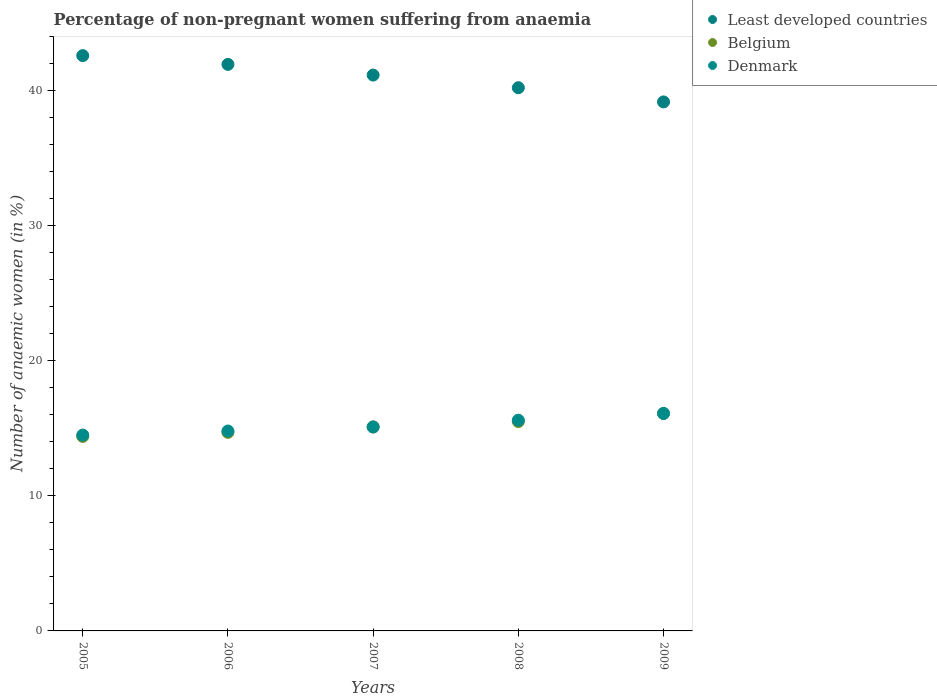How many different coloured dotlines are there?
Ensure brevity in your answer.  3. Is the number of dotlines equal to the number of legend labels?
Offer a terse response. Yes. What is the percentage of non-pregnant women suffering from anaemia in Least developed countries in 2007?
Keep it short and to the point. 41.15. Across all years, what is the minimum percentage of non-pregnant women suffering from anaemia in Least developed countries?
Provide a succinct answer. 39.16. In which year was the percentage of non-pregnant women suffering from anaemia in Denmark minimum?
Ensure brevity in your answer.  2005. What is the total percentage of non-pregnant women suffering from anaemia in Least developed countries in the graph?
Offer a terse response. 205.06. What is the difference between the percentage of non-pregnant women suffering from anaemia in Denmark in 2006 and that in 2008?
Provide a succinct answer. -0.8. What is the difference between the percentage of non-pregnant women suffering from anaemia in Belgium in 2009 and the percentage of non-pregnant women suffering from anaemia in Denmark in 2008?
Provide a succinct answer. 0.5. What is the average percentage of non-pregnant women suffering from anaemia in Denmark per year?
Ensure brevity in your answer.  15.22. In the year 2006, what is the difference between the percentage of non-pregnant women suffering from anaemia in Least developed countries and percentage of non-pregnant women suffering from anaemia in Belgium?
Provide a short and direct response. 27.24. What is the ratio of the percentage of non-pregnant women suffering from anaemia in Least developed countries in 2006 to that in 2009?
Your answer should be compact. 1.07. Is the percentage of non-pregnant women suffering from anaemia in Belgium in 2006 less than that in 2007?
Give a very brief answer. Yes. What is the difference between the highest and the second highest percentage of non-pregnant women suffering from anaemia in Denmark?
Keep it short and to the point. 0.5. What is the difference between the highest and the lowest percentage of non-pregnant women suffering from anaemia in Least developed countries?
Offer a terse response. 3.43. In how many years, is the percentage of non-pregnant women suffering from anaemia in Least developed countries greater than the average percentage of non-pregnant women suffering from anaemia in Least developed countries taken over all years?
Your answer should be very brief. 3. Is the percentage of non-pregnant women suffering from anaemia in Belgium strictly greater than the percentage of non-pregnant women suffering from anaemia in Denmark over the years?
Give a very brief answer. No. Is the percentage of non-pregnant women suffering from anaemia in Denmark strictly less than the percentage of non-pregnant women suffering from anaemia in Least developed countries over the years?
Your answer should be very brief. Yes. How many dotlines are there?
Offer a terse response. 3. How many years are there in the graph?
Keep it short and to the point. 5. Are the values on the major ticks of Y-axis written in scientific E-notation?
Your answer should be very brief. No. Does the graph contain any zero values?
Provide a succinct answer. No. Does the graph contain grids?
Make the answer very short. No. How are the legend labels stacked?
Give a very brief answer. Vertical. What is the title of the graph?
Keep it short and to the point. Percentage of non-pregnant women suffering from anaemia. What is the label or title of the X-axis?
Provide a short and direct response. Years. What is the label or title of the Y-axis?
Keep it short and to the point. Number of anaemic women (in %). What is the Number of anaemic women (in %) in Least developed countries in 2005?
Make the answer very short. 42.59. What is the Number of anaemic women (in %) in Belgium in 2005?
Your answer should be very brief. 14.4. What is the Number of anaemic women (in %) in Denmark in 2005?
Your answer should be compact. 14.5. What is the Number of anaemic women (in %) in Least developed countries in 2006?
Provide a short and direct response. 41.94. What is the Number of anaemic women (in %) of Belgium in 2006?
Offer a very short reply. 14.7. What is the Number of anaemic women (in %) of Least developed countries in 2007?
Your answer should be very brief. 41.15. What is the Number of anaemic women (in %) in Belgium in 2007?
Your response must be concise. 15.1. What is the Number of anaemic women (in %) of Denmark in 2007?
Your response must be concise. 15.1. What is the Number of anaemic women (in %) in Least developed countries in 2008?
Your answer should be compact. 40.21. What is the Number of anaemic women (in %) in Denmark in 2008?
Your answer should be compact. 15.6. What is the Number of anaemic women (in %) of Least developed countries in 2009?
Offer a terse response. 39.16. What is the Number of anaemic women (in %) of Denmark in 2009?
Offer a very short reply. 16.1. Across all years, what is the maximum Number of anaemic women (in %) of Least developed countries?
Keep it short and to the point. 42.59. Across all years, what is the minimum Number of anaemic women (in %) of Least developed countries?
Your answer should be compact. 39.16. What is the total Number of anaemic women (in %) in Least developed countries in the graph?
Provide a short and direct response. 205.06. What is the total Number of anaemic women (in %) in Belgium in the graph?
Your answer should be very brief. 75.8. What is the total Number of anaemic women (in %) of Denmark in the graph?
Your answer should be compact. 76.1. What is the difference between the Number of anaemic women (in %) of Least developed countries in 2005 and that in 2006?
Your answer should be compact. 0.65. What is the difference between the Number of anaemic women (in %) of Denmark in 2005 and that in 2006?
Ensure brevity in your answer.  -0.3. What is the difference between the Number of anaemic women (in %) of Least developed countries in 2005 and that in 2007?
Your response must be concise. 1.44. What is the difference between the Number of anaemic women (in %) of Belgium in 2005 and that in 2007?
Provide a succinct answer. -0.7. What is the difference between the Number of anaemic women (in %) of Denmark in 2005 and that in 2007?
Ensure brevity in your answer.  -0.6. What is the difference between the Number of anaemic women (in %) in Least developed countries in 2005 and that in 2008?
Your answer should be very brief. 2.38. What is the difference between the Number of anaemic women (in %) of Denmark in 2005 and that in 2008?
Give a very brief answer. -1.1. What is the difference between the Number of anaemic women (in %) in Least developed countries in 2005 and that in 2009?
Your answer should be compact. 3.43. What is the difference between the Number of anaemic women (in %) of Belgium in 2005 and that in 2009?
Offer a very short reply. -1.7. What is the difference between the Number of anaemic women (in %) in Denmark in 2005 and that in 2009?
Make the answer very short. -1.6. What is the difference between the Number of anaemic women (in %) in Least developed countries in 2006 and that in 2007?
Offer a very short reply. 0.79. What is the difference between the Number of anaemic women (in %) of Belgium in 2006 and that in 2007?
Provide a short and direct response. -0.4. What is the difference between the Number of anaemic women (in %) of Denmark in 2006 and that in 2007?
Your answer should be compact. -0.3. What is the difference between the Number of anaemic women (in %) of Least developed countries in 2006 and that in 2008?
Your answer should be very brief. 1.73. What is the difference between the Number of anaemic women (in %) in Belgium in 2006 and that in 2008?
Make the answer very short. -0.8. What is the difference between the Number of anaemic women (in %) of Denmark in 2006 and that in 2008?
Offer a terse response. -0.8. What is the difference between the Number of anaemic women (in %) of Least developed countries in 2006 and that in 2009?
Keep it short and to the point. 2.78. What is the difference between the Number of anaemic women (in %) in Belgium in 2006 and that in 2009?
Your answer should be very brief. -1.4. What is the difference between the Number of anaemic women (in %) of Least developed countries in 2007 and that in 2008?
Your response must be concise. 0.94. What is the difference between the Number of anaemic women (in %) of Belgium in 2007 and that in 2008?
Your response must be concise. -0.4. What is the difference between the Number of anaemic women (in %) of Least developed countries in 2007 and that in 2009?
Offer a terse response. 1.99. What is the difference between the Number of anaemic women (in %) in Least developed countries in 2008 and that in 2009?
Your answer should be very brief. 1.05. What is the difference between the Number of anaemic women (in %) of Belgium in 2008 and that in 2009?
Your answer should be very brief. -0.6. What is the difference between the Number of anaemic women (in %) in Denmark in 2008 and that in 2009?
Make the answer very short. -0.5. What is the difference between the Number of anaemic women (in %) of Least developed countries in 2005 and the Number of anaemic women (in %) of Belgium in 2006?
Provide a short and direct response. 27.89. What is the difference between the Number of anaemic women (in %) of Least developed countries in 2005 and the Number of anaemic women (in %) of Denmark in 2006?
Make the answer very short. 27.79. What is the difference between the Number of anaemic women (in %) in Least developed countries in 2005 and the Number of anaemic women (in %) in Belgium in 2007?
Provide a succinct answer. 27.49. What is the difference between the Number of anaemic women (in %) of Least developed countries in 2005 and the Number of anaemic women (in %) of Denmark in 2007?
Provide a succinct answer. 27.49. What is the difference between the Number of anaemic women (in %) in Least developed countries in 2005 and the Number of anaemic women (in %) in Belgium in 2008?
Make the answer very short. 27.09. What is the difference between the Number of anaemic women (in %) of Least developed countries in 2005 and the Number of anaemic women (in %) of Denmark in 2008?
Keep it short and to the point. 26.99. What is the difference between the Number of anaemic women (in %) in Belgium in 2005 and the Number of anaemic women (in %) in Denmark in 2008?
Your answer should be compact. -1.2. What is the difference between the Number of anaemic women (in %) in Least developed countries in 2005 and the Number of anaemic women (in %) in Belgium in 2009?
Give a very brief answer. 26.49. What is the difference between the Number of anaemic women (in %) in Least developed countries in 2005 and the Number of anaemic women (in %) in Denmark in 2009?
Make the answer very short. 26.49. What is the difference between the Number of anaemic women (in %) in Belgium in 2005 and the Number of anaemic women (in %) in Denmark in 2009?
Keep it short and to the point. -1.7. What is the difference between the Number of anaemic women (in %) in Least developed countries in 2006 and the Number of anaemic women (in %) in Belgium in 2007?
Offer a terse response. 26.84. What is the difference between the Number of anaemic women (in %) of Least developed countries in 2006 and the Number of anaemic women (in %) of Denmark in 2007?
Provide a short and direct response. 26.84. What is the difference between the Number of anaemic women (in %) in Belgium in 2006 and the Number of anaemic women (in %) in Denmark in 2007?
Offer a very short reply. -0.4. What is the difference between the Number of anaemic women (in %) of Least developed countries in 2006 and the Number of anaemic women (in %) of Belgium in 2008?
Your response must be concise. 26.44. What is the difference between the Number of anaemic women (in %) of Least developed countries in 2006 and the Number of anaemic women (in %) of Denmark in 2008?
Offer a terse response. 26.34. What is the difference between the Number of anaemic women (in %) in Belgium in 2006 and the Number of anaemic women (in %) in Denmark in 2008?
Offer a terse response. -0.9. What is the difference between the Number of anaemic women (in %) of Least developed countries in 2006 and the Number of anaemic women (in %) of Belgium in 2009?
Your answer should be compact. 25.84. What is the difference between the Number of anaemic women (in %) of Least developed countries in 2006 and the Number of anaemic women (in %) of Denmark in 2009?
Your answer should be compact. 25.84. What is the difference between the Number of anaemic women (in %) of Least developed countries in 2007 and the Number of anaemic women (in %) of Belgium in 2008?
Offer a terse response. 25.65. What is the difference between the Number of anaemic women (in %) of Least developed countries in 2007 and the Number of anaemic women (in %) of Denmark in 2008?
Give a very brief answer. 25.55. What is the difference between the Number of anaemic women (in %) in Least developed countries in 2007 and the Number of anaemic women (in %) in Belgium in 2009?
Make the answer very short. 25.05. What is the difference between the Number of anaemic women (in %) in Least developed countries in 2007 and the Number of anaemic women (in %) in Denmark in 2009?
Your answer should be compact. 25.05. What is the difference between the Number of anaemic women (in %) of Belgium in 2007 and the Number of anaemic women (in %) of Denmark in 2009?
Your answer should be very brief. -1. What is the difference between the Number of anaemic women (in %) of Least developed countries in 2008 and the Number of anaemic women (in %) of Belgium in 2009?
Provide a short and direct response. 24.11. What is the difference between the Number of anaemic women (in %) of Least developed countries in 2008 and the Number of anaemic women (in %) of Denmark in 2009?
Make the answer very short. 24.11. What is the average Number of anaemic women (in %) of Least developed countries per year?
Offer a very short reply. 41.01. What is the average Number of anaemic women (in %) of Belgium per year?
Offer a very short reply. 15.16. What is the average Number of anaemic women (in %) in Denmark per year?
Keep it short and to the point. 15.22. In the year 2005, what is the difference between the Number of anaemic women (in %) of Least developed countries and Number of anaemic women (in %) of Belgium?
Offer a terse response. 28.19. In the year 2005, what is the difference between the Number of anaemic women (in %) in Least developed countries and Number of anaemic women (in %) in Denmark?
Keep it short and to the point. 28.09. In the year 2005, what is the difference between the Number of anaemic women (in %) of Belgium and Number of anaemic women (in %) of Denmark?
Provide a succinct answer. -0.1. In the year 2006, what is the difference between the Number of anaemic women (in %) of Least developed countries and Number of anaemic women (in %) of Belgium?
Provide a succinct answer. 27.24. In the year 2006, what is the difference between the Number of anaemic women (in %) of Least developed countries and Number of anaemic women (in %) of Denmark?
Provide a succinct answer. 27.14. In the year 2007, what is the difference between the Number of anaemic women (in %) in Least developed countries and Number of anaemic women (in %) in Belgium?
Make the answer very short. 26.05. In the year 2007, what is the difference between the Number of anaemic women (in %) in Least developed countries and Number of anaemic women (in %) in Denmark?
Your answer should be very brief. 26.05. In the year 2008, what is the difference between the Number of anaemic women (in %) in Least developed countries and Number of anaemic women (in %) in Belgium?
Give a very brief answer. 24.71. In the year 2008, what is the difference between the Number of anaemic women (in %) of Least developed countries and Number of anaemic women (in %) of Denmark?
Give a very brief answer. 24.61. In the year 2008, what is the difference between the Number of anaemic women (in %) of Belgium and Number of anaemic women (in %) of Denmark?
Provide a short and direct response. -0.1. In the year 2009, what is the difference between the Number of anaemic women (in %) of Least developed countries and Number of anaemic women (in %) of Belgium?
Give a very brief answer. 23.06. In the year 2009, what is the difference between the Number of anaemic women (in %) in Least developed countries and Number of anaemic women (in %) in Denmark?
Offer a terse response. 23.06. What is the ratio of the Number of anaemic women (in %) of Least developed countries in 2005 to that in 2006?
Provide a succinct answer. 1.02. What is the ratio of the Number of anaemic women (in %) in Belgium in 2005 to that in 2006?
Ensure brevity in your answer.  0.98. What is the ratio of the Number of anaemic women (in %) of Denmark in 2005 to that in 2006?
Provide a succinct answer. 0.98. What is the ratio of the Number of anaemic women (in %) of Least developed countries in 2005 to that in 2007?
Provide a succinct answer. 1.03. What is the ratio of the Number of anaemic women (in %) in Belgium in 2005 to that in 2007?
Offer a very short reply. 0.95. What is the ratio of the Number of anaemic women (in %) in Denmark in 2005 to that in 2007?
Your response must be concise. 0.96. What is the ratio of the Number of anaemic women (in %) of Least developed countries in 2005 to that in 2008?
Make the answer very short. 1.06. What is the ratio of the Number of anaemic women (in %) in Belgium in 2005 to that in 2008?
Provide a succinct answer. 0.93. What is the ratio of the Number of anaemic women (in %) in Denmark in 2005 to that in 2008?
Offer a terse response. 0.93. What is the ratio of the Number of anaemic women (in %) of Least developed countries in 2005 to that in 2009?
Give a very brief answer. 1.09. What is the ratio of the Number of anaemic women (in %) in Belgium in 2005 to that in 2009?
Offer a very short reply. 0.89. What is the ratio of the Number of anaemic women (in %) of Denmark in 2005 to that in 2009?
Ensure brevity in your answer.  0.9. What is the ratio of the Number of anaemic women (in %) of Least developed countries in 2006 to that in 2007?
Your response must be concise. 1.02. What is the ratio of the Number of anaemic women (in %) in Belgium in 2006 to that in 2007?
Offer a terse response. 0.97. What is the ratio of the Number of anaemic women (in %) in Denmark in 2006 to that in 2007?
Keep it short and to the point. 0.98. What is the ratio of the Number of anaemic women (in %) in Least developed countries in 2006 to that in 2008?
Your answer should be compact. 1.04. What is the ratio of the Number of anaemic women (in %) in Belgium in 2006 to that in 2008?
Your answer should be compact. 0.95. What is the ratio of the Number of anaemic women (in %) of Denmark in 2006 to that in 2008?
Your answer should be compact. 0.95. What is the ratio of the Number of anaemic women (in %) in Least developed countries in 2006 to that in 2009?
Provide a short and direct response. 1.07. What is the ratio of the Number of anaemic women (in %) in Belgium in 2006 to that in 2009?
Make the answer very short. 0.91. What is the ratio of the Number of anaemic women (in %) in Denmark in 2006 to that in 2009?
Your answer should be compact. 0.92. What is the ratio of the Number of anaemic women (in %) of Least developed countries in 2007 to that in 2008?
Keep it short and to the point. 1.02. What is the ratio of the Number of anaemic women (in %) of Belgium in 2007 to that in 2008?
Your answer should be compact. 0.97. What is the ratio of the Number of anaemic women (in %) in Denmark in 2007 to that in 2008?
Offer a terse response. 0.97. What is the ratio of the Number of anaemic women (in %) in Least developed countries in 2007 to that in 2009?
Keep it short and to the point. 1.05. What is the ratio of the Number of anaemic women (in %) in Belgium in 2007 to that in 2009?
Give a very brief answer. 0.94. What is the ratio of the Number of anaemic women (in %) in Denmark in 2007 to that in 2009?
Offer a terse response. 0.94. What is the ratio of the Number of anaemic women (in %) in Least developed countries in 2008 to that in 2009?
Your answer should be compact. 1.03. What is the ratio of the Number of anaemic women (in %) of Belgium in 2008 to that in 2009?
Your answer should be compact. 0.96. What is the ratio of the Number of anaemic women (in %) of Denmark in 2008 to that in 2009?
Offer a terse response. 0.97. What is the difference between the highest and the second highest Number of anaemic women (in %) of Least developed countries?
Your answer should be very brief. 0.65. What is the difference between the highest and the second highest Number of anaemic women (in %) of Belgium?
Ensure brevity in your answer.  0.6. What is the difference between the highest and the second highest Number of anaemic women (in %) in Denmark?
Provide a succinct answer. 0.5. What is the difference between the highest and the lowest Number of anaemic women (in %) in Least developed countries?
Offer a very short reply. 3.43. What is the difference between the highest and the lowest Number of anaemic women (in %) of Belgium?
Offer a very short reply. 1.7. What is the difference between the highest and the lowest Number of anaemic women (in %) in Denmark?
Offer a very short reply. 1.6. 